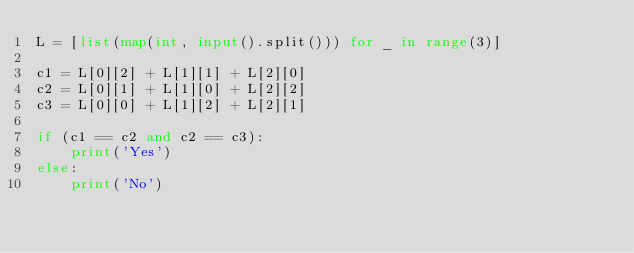Convert code to text. <code><loc_0><loc_0><loc_500><loc_500><_Python_>L = [list(map(int, input().split())) for _ in range(3)]

c1 = L[0][2] + L[1][1] + L[2][0]
c2 = L[0][1] + L[1][0] + L[2][2]
c3 = L[0][0] + L[1][2] + L[2][1]

if (c1 == c2 and c2 == c3):
    print('Yes')
else:
    print('No')
</code> 